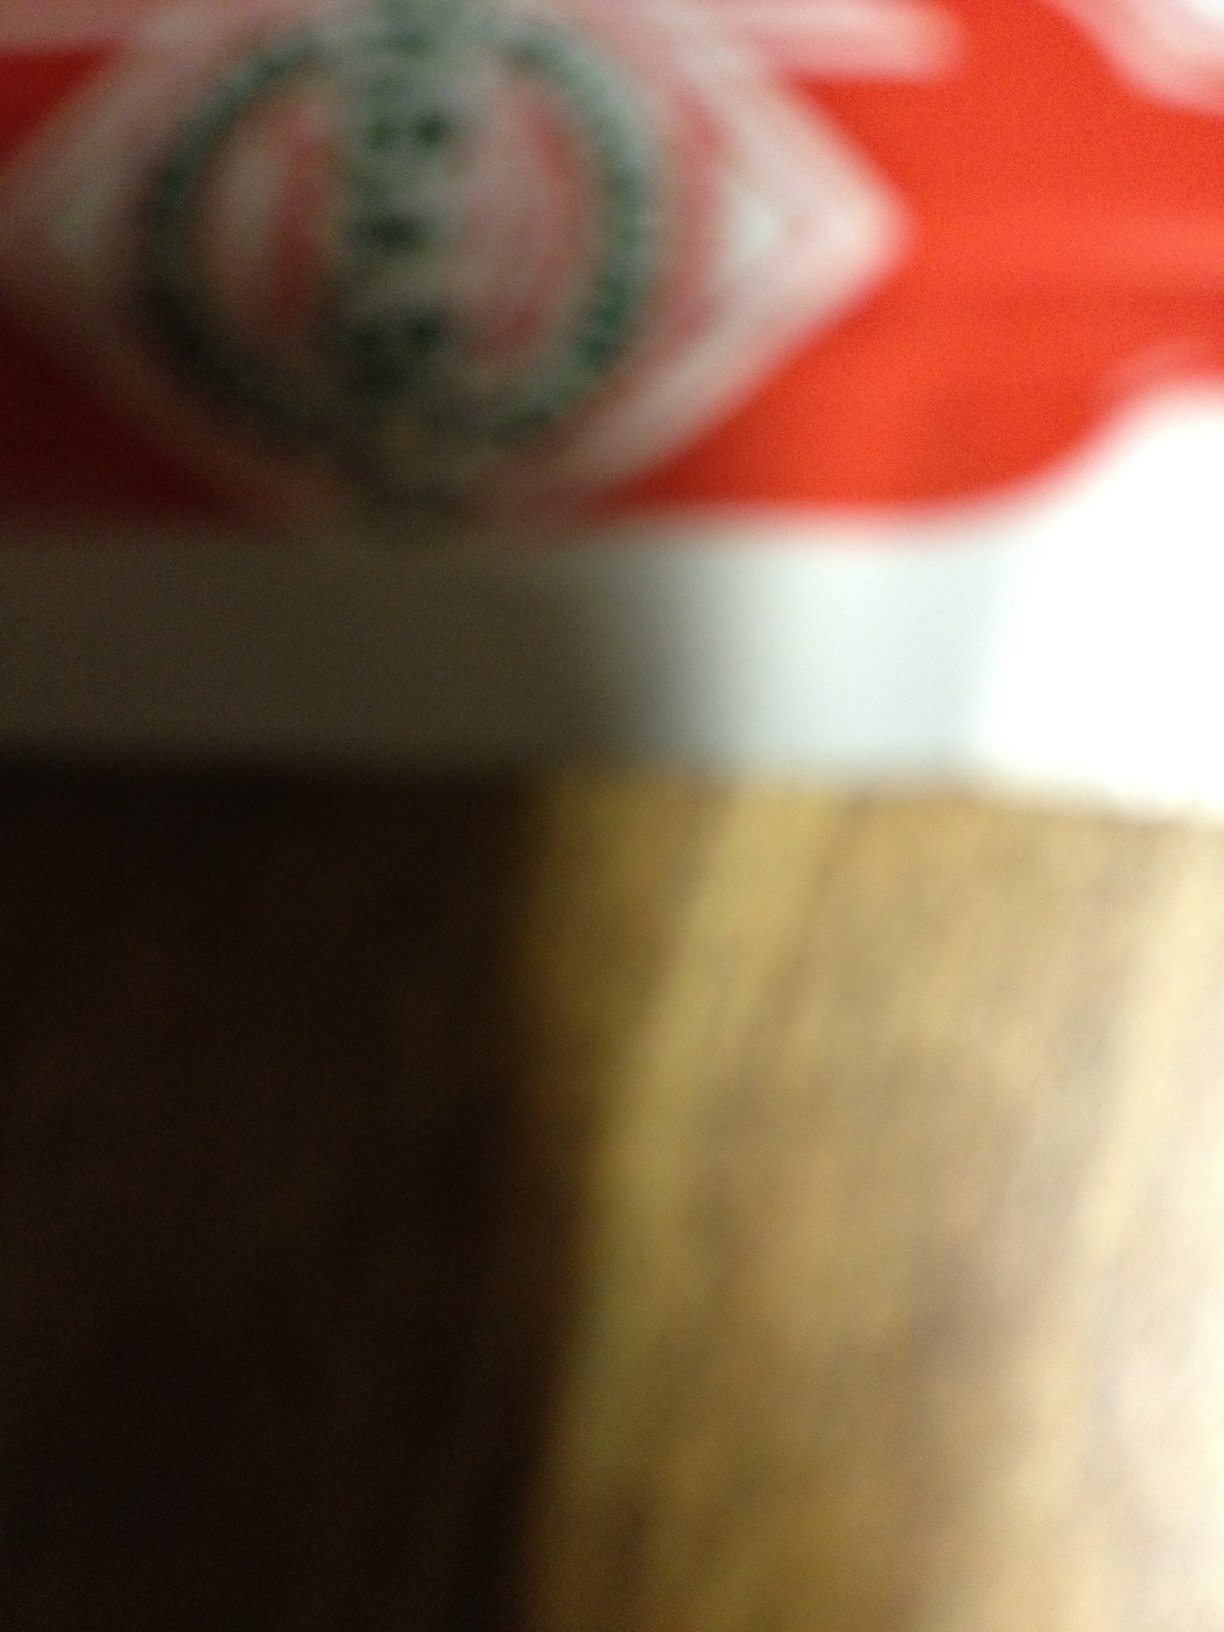What's this package? Given the blurry image it is difficult to provide a definitive answer. The visible details suggest it might be a packaged product, possibly food given the red and green colors which are often used in food packaging. Due to the lack of clarity, a more accurate identification isn't possible without a clearer image. 